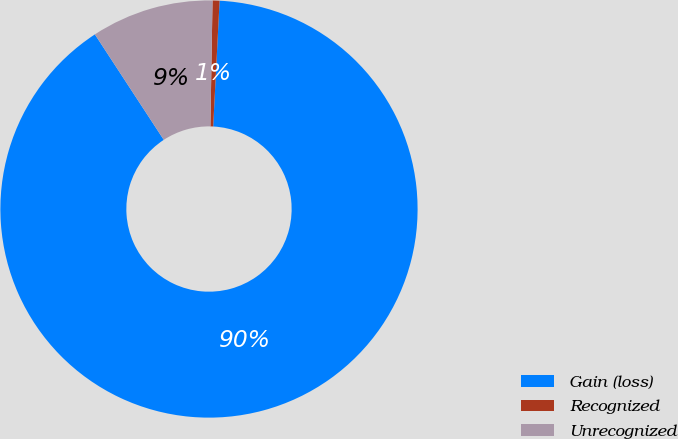Convert chart to OTSL. <chart><loc_0><loc_0><loc_500><loc_500><pie_chart><fcel>Gain (loss)<fcel>Recognized<fcel>Unrecognized<nl><fcel>89.98%<fcel>0.54%<fcel>9.48%<nl></chart> 